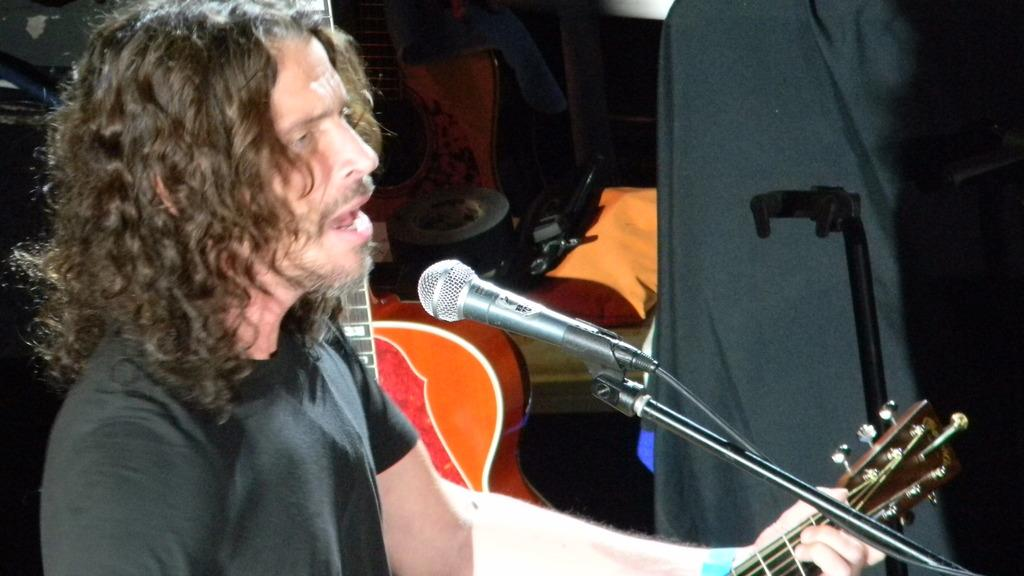Who or what is present in the image? There is a person in the image. What object is associated with the person in the image? There is a microphone in the image. What musical instruments can be seen in the image? There are guitars in the image. Can you describe any other objects in the image? There are some unspecified objects in the image. What type of carriage can be seen in the image? There is no carriage present in the image. What does the image smell like? The image is a visual representation and does not have a smell. 